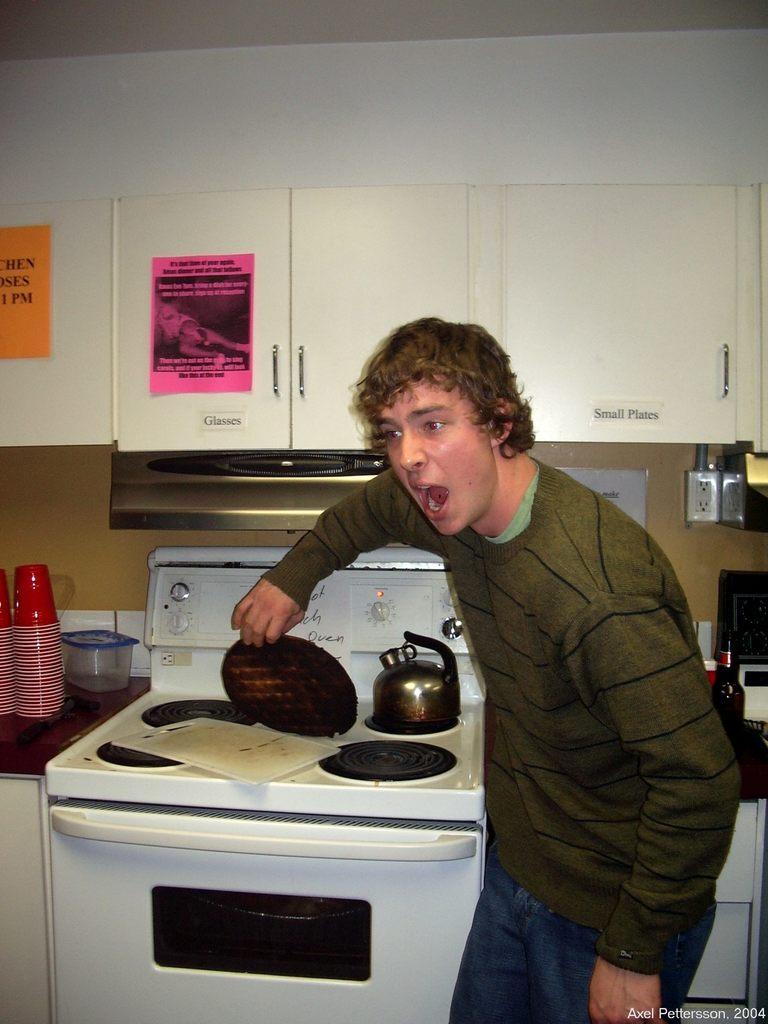What kind of plates in that cabinet?
Offer a very short reply. Small. What year was the photo taken?
Give a very brief answer. 2004. 